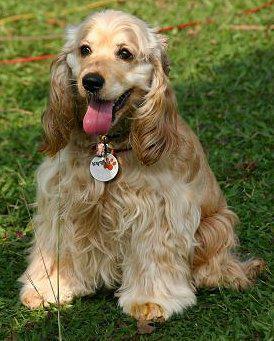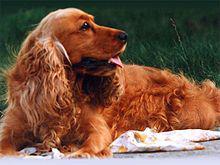The first image is the image on the left, the second image is the image on the right. Analyze the images presented: Is the assertion "At least one of the dogs is laying down." valid? Answer yes or no. Yes. The first image is the image on the left, the second image is the image on the right. Analyze the images presented: Is the assertion "One curly eared dog is facing right." valid? Answer yes or no. Yes. 